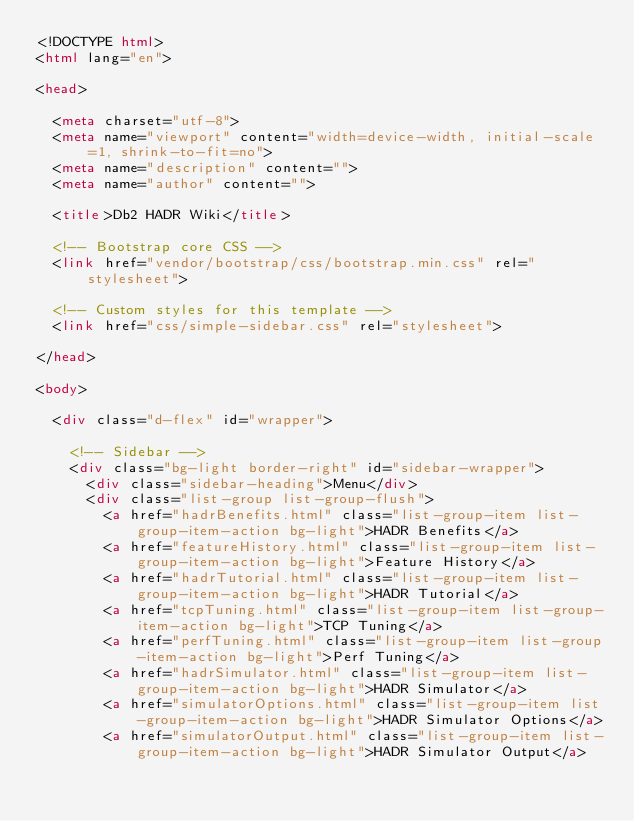Convert code to text. <code><loc_0><loc_0><loc_500><loc_500><_HTML_><!DOCTYPE html>
<html lang="en">

<head>

  <meta charset="utf-8">
  <meta name="viewport" content="width=device-width, initial-scale=1, shrink-to-fit=no">
  <meta name="description" content="">
  <meta name="author" content="">

  <title>Db2 HADR Wiki</title>

  <!-- Bootstrap core CSS -->
  <link href="vendor/bootstrap/css/bootstrap.min.css" rel="stylesheet">

  <!-- Custom styles for this template -->
  <link href="css/simple-sidebar.css" rel="stylesheet">

</head>

<body>

  <div class="d-flex" id="wrapper">

    <!-- Sidebar -->
    <div class="bg-light border-right" id="sidebar-wrapper">
      <div class="sidebar-heading">Menu</div>
      <div class="list-group list-group-flush">
        <a href="hadrBenefits.html" class="list-group-item list-group-item-action bg-light">HADR Benefits</a>
        <a href="featureHistory.html" class="list-group-item list-group-item-action bg-light">Feature History</a>
        <a href="hadrTutorial.html" class="list-group-item list-group-item-action bg-light">HADR Tutorial</a>
        <a href="tcpTuning.html" class="list-group-item list-group-item-action bg-light">TCP Tuning</a>
        <a href="perfTuning.html" class="list-group-item list-group-item-action bg-light">Perf Tuning</a>
        <a href="hadrSimulator.html" class="list-group-item list-group-item-action bg-light">HADR Simulator</a>
        <a href="simulatorOptions.html" class="list-group-item list-group-item-action bg-light">HADR Simulator Options</a>
        <a href="simulatorOutput.html" class="list-group-item list-group-item-action bg-light">HADR Simulator Output</a></code> 